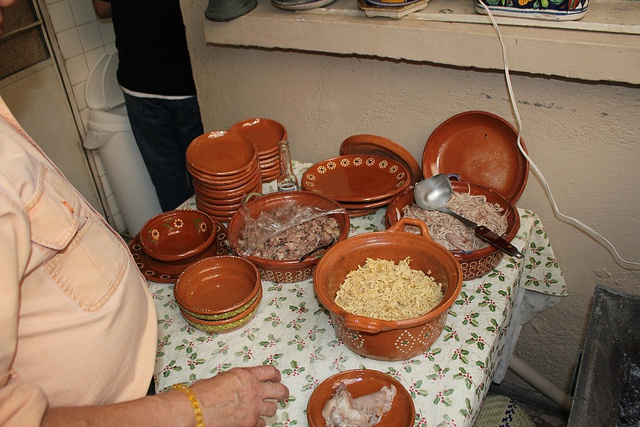Describe the objects in this image and their specific colors. I can see people in brown, tan, and salmon tones, dining table in brown, darkgray, and lightgray tones, bowl in brown, tan, and maroon tones, people in brown, black, gray, maroon, and darkgray tones, and bowl in brown, gray, and maroon tones in this image. 